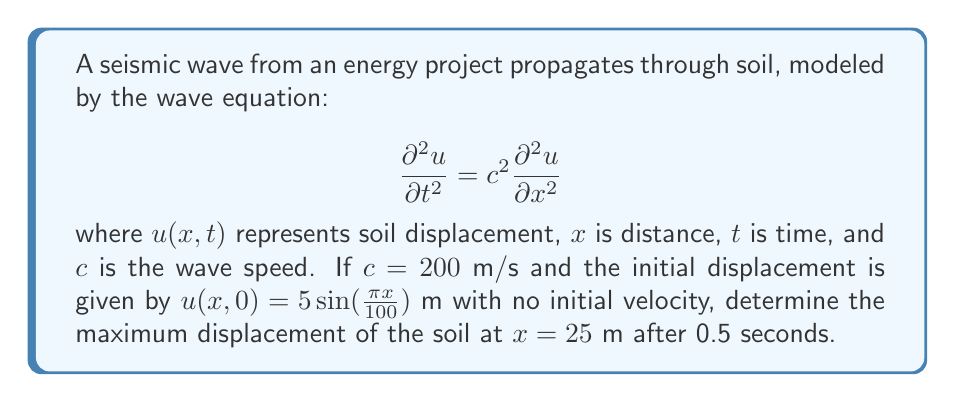Provide a solution to this math problem. 1) The general solution to the wave equation is given by D'Alembert's formula:

   $$u(x,t) = \frac{1}{2}[f(x-ct) + f(x+ct)] + \frac{1}{2c}\int_{x-ct}^{x+ct} g(s)ds$$

   where $f(x)$ is the initial displacement and $g(x)$ is the initial velocity.

2) In this case, $f(x) = 5\sin(\frac{\pi x}{100})$ and $g(x) = 0$.

3) Substituting these into D'Alembert's formula:

   $$u(x,t) = \frac{1}{2}[5\sin(\frac{\pi(x-ct)}{100}) + 5\sin(\frac{\pi(x+ct)}{100})]$$

4) Using the trigonometric identity for the sum of sines:

   $$u(x,t) = 5\sin(\frac{\pi x}{100})\cos(\frac{\pi ct}{100})$$

5) At $x = 25$ m and $t = 0.5$ s:

   $$u(25, 0.5) = 5\sin(\frac{25\pi}{100})\cos(\frac{0.5 \cdot 200\pi}{100})$$

6) Simplifying:

   $$u(25, 0.5) = 5\sin(\frac{\pi}{4})\cos(\pi) = 5 \cdot \frac{\sqrt{2}}{2} \cdot (-1) = -\frac{5\sqrt{2}}{2}$$

7) The absolute value of this gives the maximum displacement:

   $$|u(25, 0.5)| = \frac{5\sqrt{2}}{2} \approx 3.54$$
Answer: $\frac{5\sqrt{2}}{2}$ m 